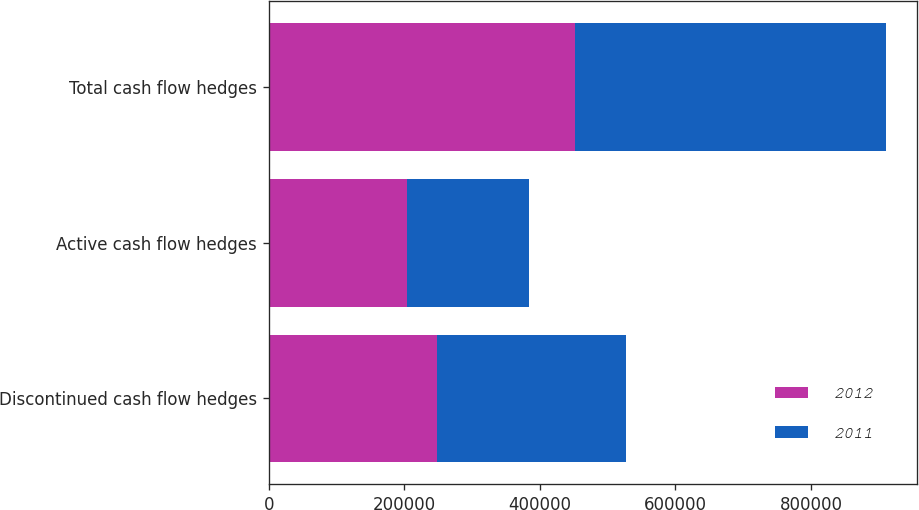Convert chart to OTSL. <chart><loc_0><loc_0><loc_500><loc_500><stacked_bar_chart><ecel><fcel>Discontinued cash flow hedges<fcel>Active cash flow hedges<fcel>Total cash flow hedges<nl><fcel>2012<fcel>247983<fcel>204358<fcel>452341<nl><fcel>2011<fcel>279091<fcel>178862<fcel>457953<nl></chart> 